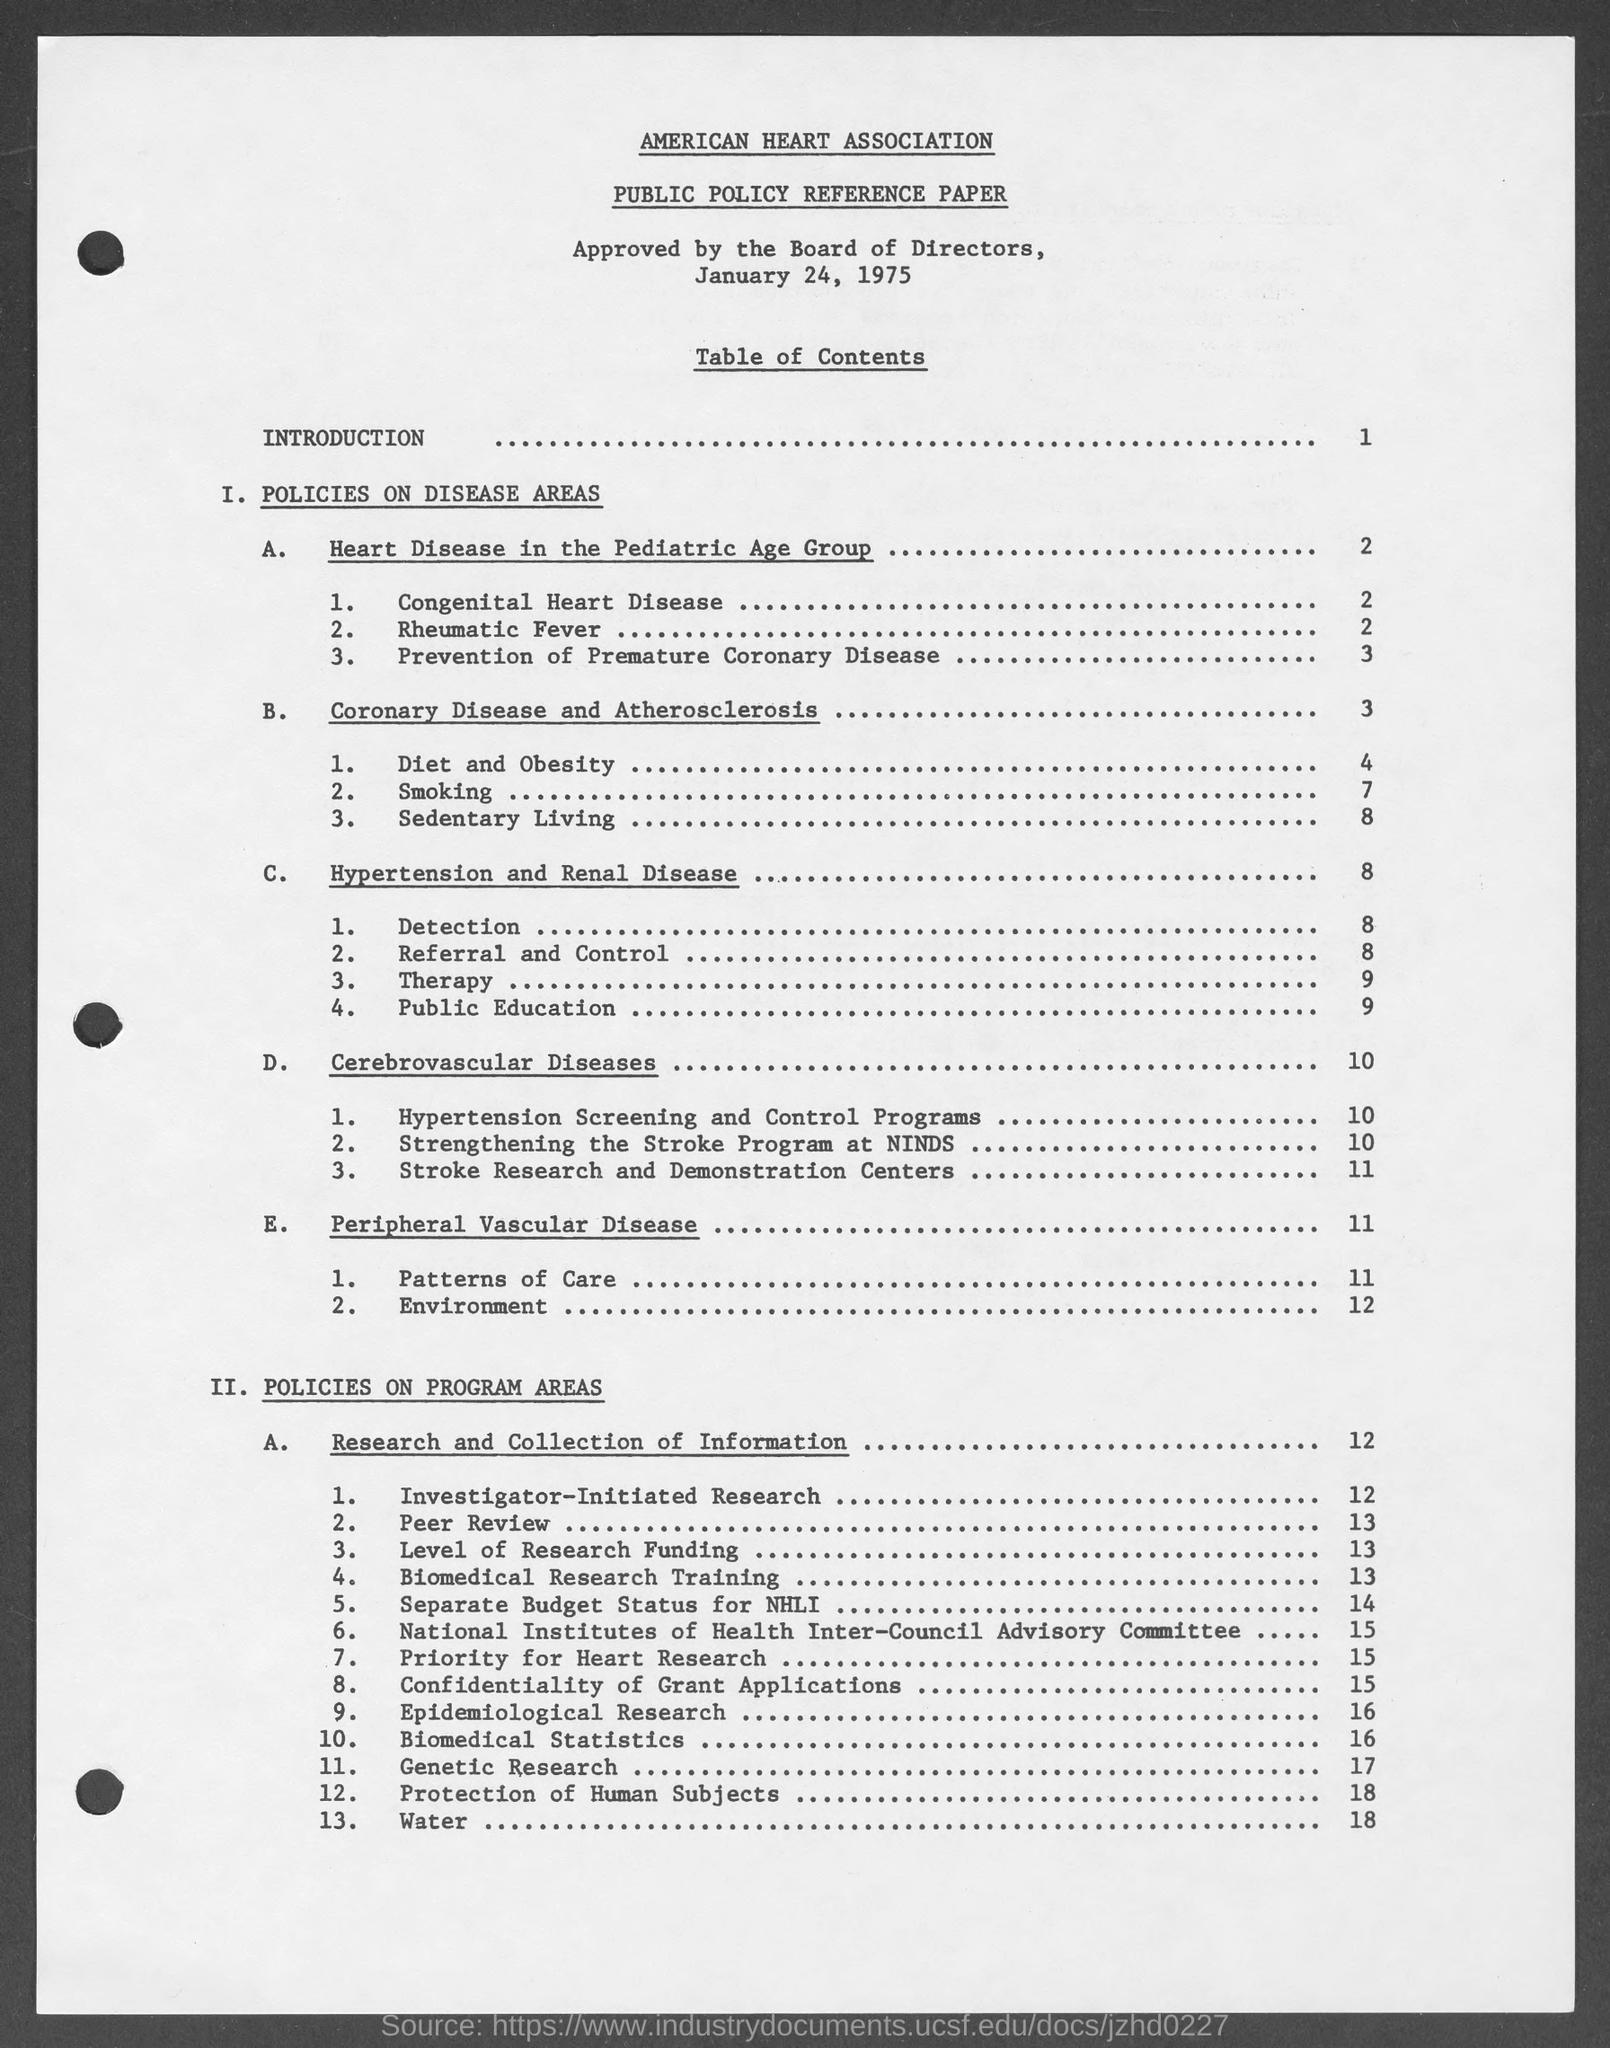Point out several critical features in this image. The American Heart Association is named in the given page. Obesity and diet are mentioned in page 4. The paper mentioned in the given page is titled 'Public Policy Reference Paper.' The date mentioned in the given page is January 24, 1975. Page 1 contains an introduction. 